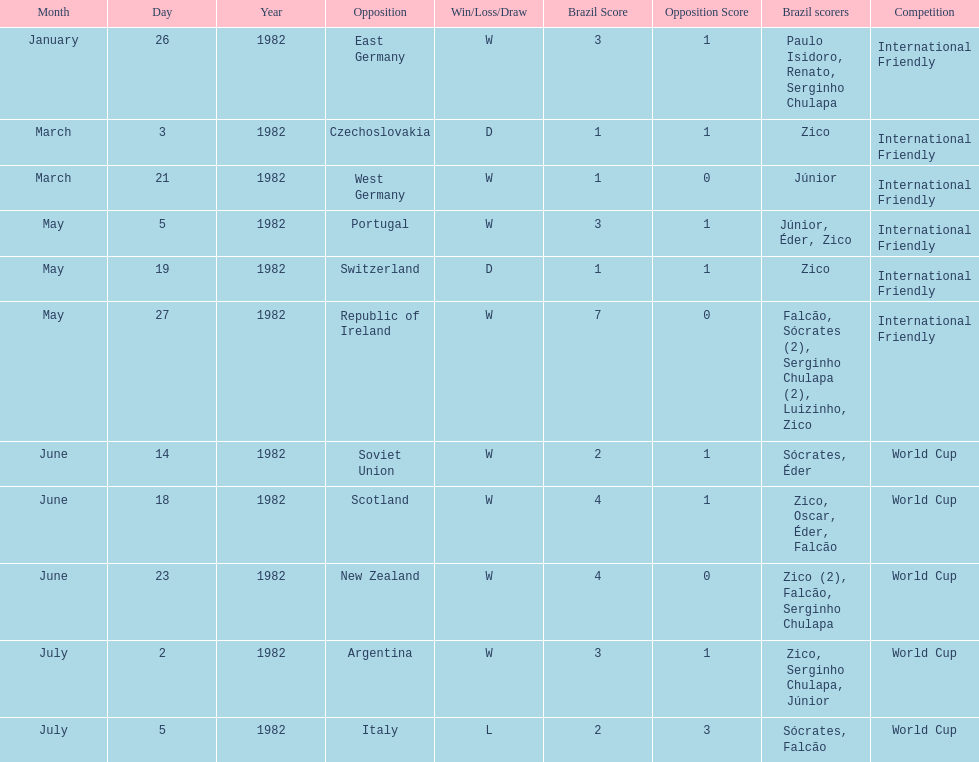Who was this team's next opponent after facing the soviet union on june 14? Scotland. 